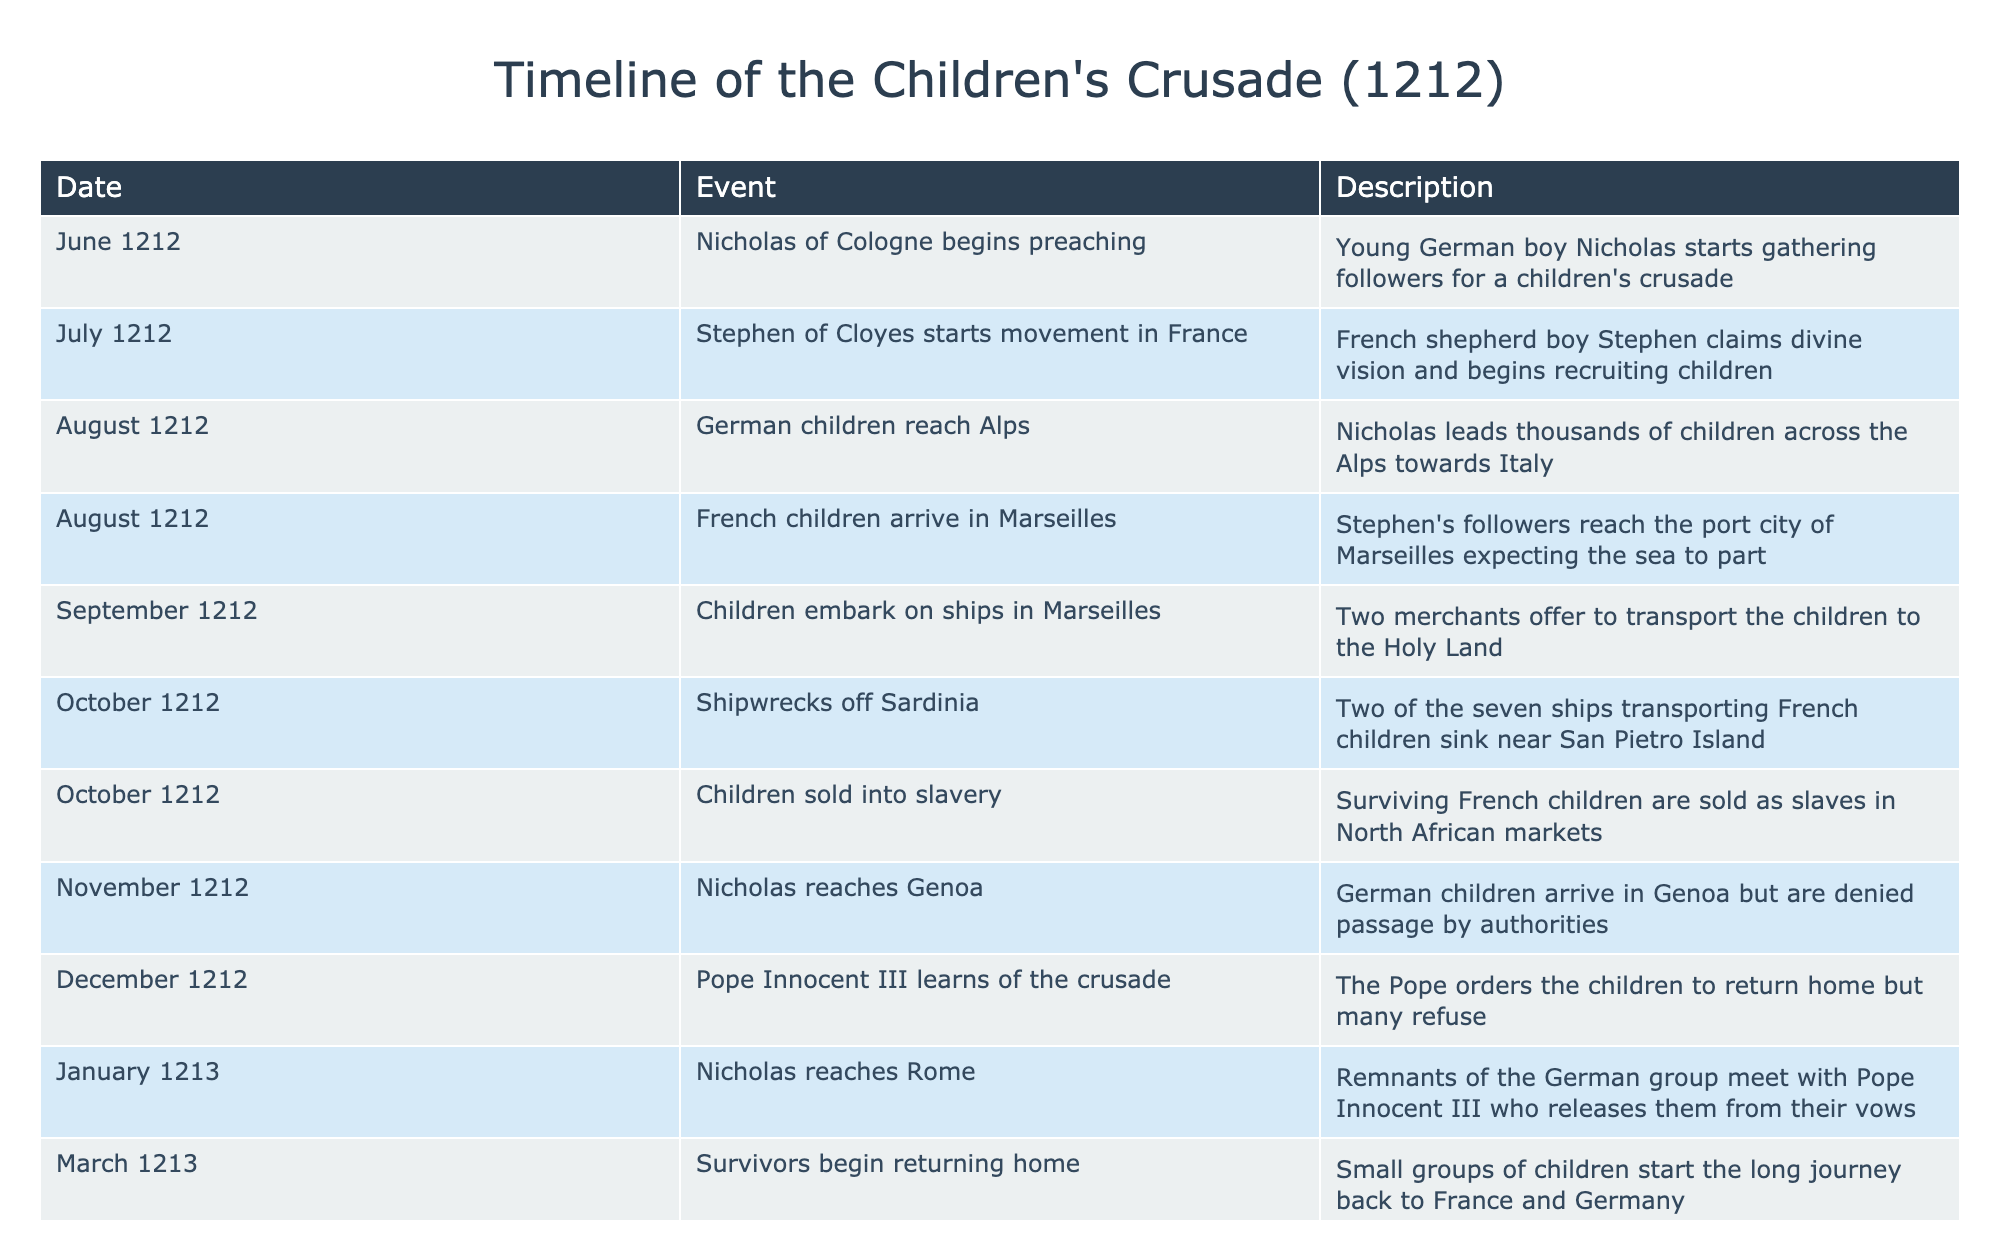What event marked the beginning of the Children's Crusade? According to the table, the Children's Crusade began when Nicholas of Cologne started preaching in June 1212.
Answer: Nicholas of Cologne begins preaching How many significant events occurred in October 1212? The table shows two significant events in October 1212: the shipwrecks off Sardinia and the children being sold into slavery.
Answer: 2 What was the outcome for surviving French children after the shipwrecks? The table states that after the shipwrecks, the surviving French children were sold into slavery in North African markets.
Answer: Sold into slavery When did Nicholas meet with Pope Innocent III, and what was the result? Nicholas met with Pope Innocent III in January 1213, where the Pope released the remnants of the German group from their vows.
Answer: January 1213; released from vows What was the journey followed by the German children from starting to return home? German children initially traveled across the Alps and later reached Genoa in November 1212 but were denied passage before meeting Pope Innocent III in January 1213 to return home. This indicates a challenging and lengthy journey.
Answer: Across the Alps, then to Genoa, meeting the Pope Did the Children's Crusade end positively for the children involved? The table shows several negative outcomes for the children involved, including shipwrecks and being sold into slavery, suggesting a negative conclusion to the Crusade.
Answer: No, it ended negatively 